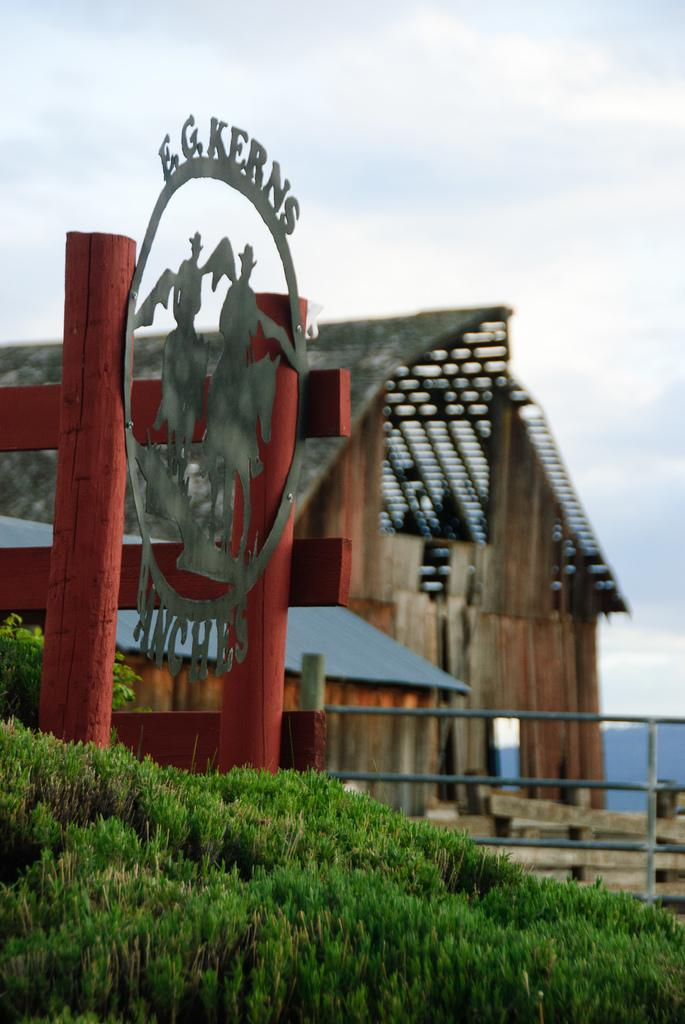Provide a one-sentence caption for the provided image. Silhouettes of cowboys on horses are in the center of a metal E.G. Kerns Ranches sign. 